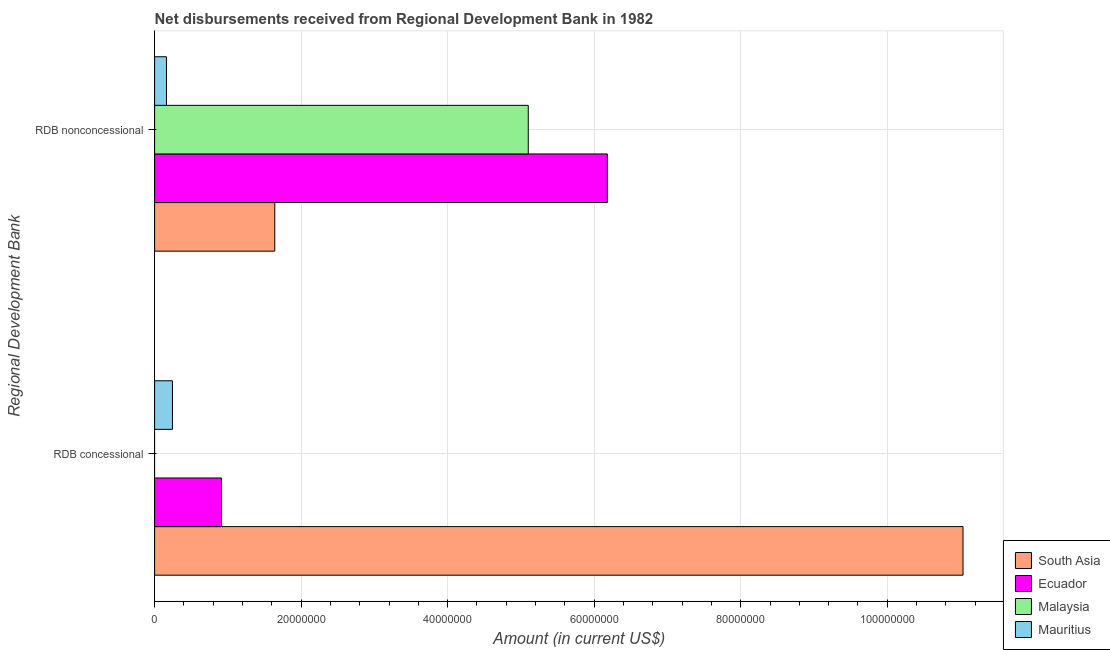How many different coloured bars are there?
Give a very brief answer. 4. Are the number of bars per tick equal to the number of legend labels?
Make the answer very short. No. How many bars are there on the 1st tick from the top?
Keep it short and to the point. 4. What is the label of the 2nd group of bars from the top?
Your answer should be compact. RDB concessional. What is the net concessional disbursements from rdb in Mauritius?
Keep it short and to the point. 2.44e+06. Across all countries, what is the maximum net non concessional disbursements from rdb?
Keep it short and to the point. 6.18e+07. Across all countries, what is the minimum net non concessional disbursements from rdb?
Give a very brief answer. 1.62e+06. What is the total net concessional disbursements from rdb in the graph?
Your answer should be compact. 1.22e+08. What is the difference between the net non concessional disbursements from rdb in Mauritius and that in Ecuador?
Offer a very short reply. -6.02e+07. What is the difference between the net non concessional disbursements from rdb in Mauritius and the net concessional disbursements from rdb in Ecuador?
Ensure brevity in your answer.  -7.51e+06. What is the average net non concessional disbursements from rdb per country?
Provide a succinct answer. 3.27e+07. What is the difference between the net non concessional disbursements from rdb and net concessional disbursements from rdb in South Asia?
Your answer should be very brief. -9.39e+07. What is the ratio of the net concessional disbursements from rdb in Mauritius to that in Ecuador?
Your answer should be very brief. 0.27. How many bars are there?
Keep it short and to the point. 7. How many countries are there in the graph?
Offer a terse response. 4. Are the values on the major ticks of X-axis written in scientific E-notation?
Make the answer very short. No. Does the graph contain any zero values?
Ensure brevity in your answer.  Yes. Does the graph contain grids?
Offer a very short reply. Yes. How many legend labels are there?
Provide a succinct answer. 4. How are the legend labels stacked?
Your answer should be compact. Vertical. What is the title of the graph?
Make the answer very short. Net disbursements received from Regional Development Bank in 1982. What is the label or title of the X-axis?
Offer a terse response. Amount (in current US$). What is the label or title of the Y-axis?
Provide a succinct answer. Regional Development Bank. What is the Amount (in current US$) of South Asia in RDB concessional?
Offer a terse response. 1.10e+08. What is the Amount (in current US$) of Ecuador in RDB concessional?
Your response must be concise. 9.13e+06. What is the Amount (in current US$) in Mauritius in RDB concessional?
Your answer should be compact. 2.44e+06. What is the Amount (in current US$) of South Asia in RDB nonconcessional?
Make the answer very short. 1.64e+07. What is the Amount (in current US$) in Ecuador in RDB nonconcessional?
Offer a terse response. 6.18e+07. What is the Amount (in current US$) in Malaysia in RDB nonconcessional?
Keep it short and to the point. 5.10e+07. What is the Amount (in current US$) of Mauritius in RDB nonconcessional?
Offer a very short reply. 1.62e+06. Across all Regional Development Bank, what is the maximum Amount (in current US$) of South Asia?
Give a very brief answer. 1.10e+08. Across all Regional Development Bank, what is the maximum Amount (in current US$) in Ecuador?
Your answer should be very brief. 6.18e+07. Across all Regional Development Bank, what is the maximum Amount (in current US$) of Malaysia?
Offer a terse response. 5.10e+07. Across all Regional Development Bank, what is the maximum Amount (in current US$) of Mauritius?
Give a very brief answer. 2.44e+06. Across all Regional Development Bank, what is the minimum Amount (in current US$) of South Asia?
Offer a very short reply. 1.64e+07. Across all Regional Development Bank, what is the minimum Amount (in current US$) of Ecuador?
Offer a terse response. 9.13e+06. Across all Regional Development Bank, what is the minimum Amount (in current US$) in Malaysia?
Your response must be concise. 0. Across all Regional Development Bank, what is the minimum Amount (in current US$) in Mauritius?
Offer a terse response. 1.62e+06. What is the total Amount (in current US$) of South Asia in the graph?
Offer a terse response. 1.27e+08. What is the total Amount (in current US$) of Ecuador in the graph?
Offer a terse response. 7.09e+07. What is the total Amount (in current US$) of Malaysia in the graph?
Offer a terse response. 5.10e+07. What is the total Amount (in current US$) in Mauritius in the graph?
Your response must be concise. 4.06e+06. What is the difference between the Amount (in current US$) in South Asia in RDB concessional and that in RDB nonconcessional?
Offer a very short reply. 9.39e+07. What is the difference between the Amount (in current US$) of Ecuador in RDB concessional and that in RDB nonconcessional?
Give a very brief answer. -5.27e+07. What is the difference between the Amount (in current US$) in Mauritius in RDB concessional and that in RDB nonconcessional?
Keep it short and to the point. 8.17e+05. What is the difference between the Amount (in current US$) of South Asia in RDB concessional and the Amount (in current US$) of Ecuador in RDB nonconcessional?
Keep it short and to the point. 4.85e+07. What is the difference between the Amount (in current US$) in South Asia in RDB concessional and the Amount (in current US$) in Malaysia in RDB nonconcessional?
Your answer should be very brief. 5.93e+07. What is the difference between the Amount (in current US$) in South Asia in RDB concessional and the Amount (in current US$) in Mauritius in RDB nonconcessional?
Provide a short and direct response. 1.09e+08. What is the difference between the Amount (in current US$) in Ecuador in RDB concessional and the Amount (in current US$) in Malaysia in RDB nonconcessional?
Give a very brief answer. -4.19e+07. What is the difference between the Amount (in current US$) in Ecuador in RDB concessional and the Amount (in current US$) in Mauritius in RDB nonconcessional?
Make the answer very short. 7.51e+06. What is the average Amount (in current US$) of South Asia per Regional Development Bank?
Provide a short and direct response. 6.34e+07. What is the average Amount (in current US$) of Ecuador per Regional Development Bank?
Offer a very short reply. 3.55e+07. What is the average Amount (in current US$) of Malaysia per Regional Development Bank?
Your answer should be very brief. 2.55e+07. What is the average Amount (in current US$) of Mauritius per Regional Development Bank?
Offer a very short reply. 2.03e+06. What is the difference between the Amount (in current US$) of South Asia and Amount (in current US$) of Ecuador in RDB concessional?
Provide a short and direct response. 1.01e+08. What is the difference between the Amount (in current US$) in South Asia and Amount (in current US$) in Mauritius in RDB concessional?
Give a very brief answer. 1.08e+08. What is the difference between the Amount (in current US$) of Ecuador and Amount (in current US$) of Mauritius in RDB concessional?
Provide a succinct answer. 6.69e+06. What is the difference between the Amount (in current US$) in South Asia and Amount (in current US$) in Ecuador in RDB nonconcessional?
Your response must be concise. -4.54e+07. What is the difference between the Amount (in current US$) of South Asia and Amount (in current US$) of Malaysia in RDB nonconcessional?
Offer a terse response. -3.46e+07. What is the difference between the Amount (in current US$) of South Asia and Amount (in current US$) of Mauritius in RDB nonconcessional?
Provide a succinct answer. 1.48e+07. What is the difference between the Amount (in current US$) of Ecuador and Amount (in current US$) of Malaysia in RDB nonconcessional?
Your answer should be compact. 1.08e+07. What is the difference between the Amount (in current US$) of Ecuador and Amount (in current US$) of Mauritius in RDB nonconcessional?
Your answer should be compact. 6.02e+07. What is the difference between the Amount (in current US$) in Malaysia and Amount (in current US$) in Mauritius in RDB nonconcessional?
Your answer should be very brief. 4.94e+07. What is the ratio of the Amount (in current US$) of South Asia in RDB concessional to that in RDB nonconcessional?
Keep it short and to the point. 6.73. What is the ratio of the Amount (in current US$) in Ecuador in RDB concessional to that in RDB nonconcessional?
Make the answer very short. 0.15. What is the ratio of the Amount (in current US$) of Mauritius in RDB concessional to that in RDB nonconcessional?
Provide a succinct answer. 1.5. What is the difference between the highest and the second highest Amount (in current US$) of South Asia?
Your response must be concise. 9.39e+07. What is the difference between the highest and the second highest Amount (in current US$) of Ecuador?
Your answer should be very brief. 5.27e+07. What is the difference between the highest and the second highest Amount (in current US$) in Mauritius?
Give a very brief answer. 8.17e+05. What is the difference between the highest and the lowest Amount (in current US$) of South Asia?
Keep it short and to the point. 9.39e+07. What is the difference between the highest and the lowest Amount (in current US$) in Ecuador?
Give a very brief answer. 5.27e+07. What is the difference between the highest and the lowest Amount (in current US$) of Malaysia?
Provide a short and direct response. 5.10e+07. What is the difference between the highest and the lowest Amount (in current US$) of Mauritius?
Keep it short and to the point. 8.17e+05. 